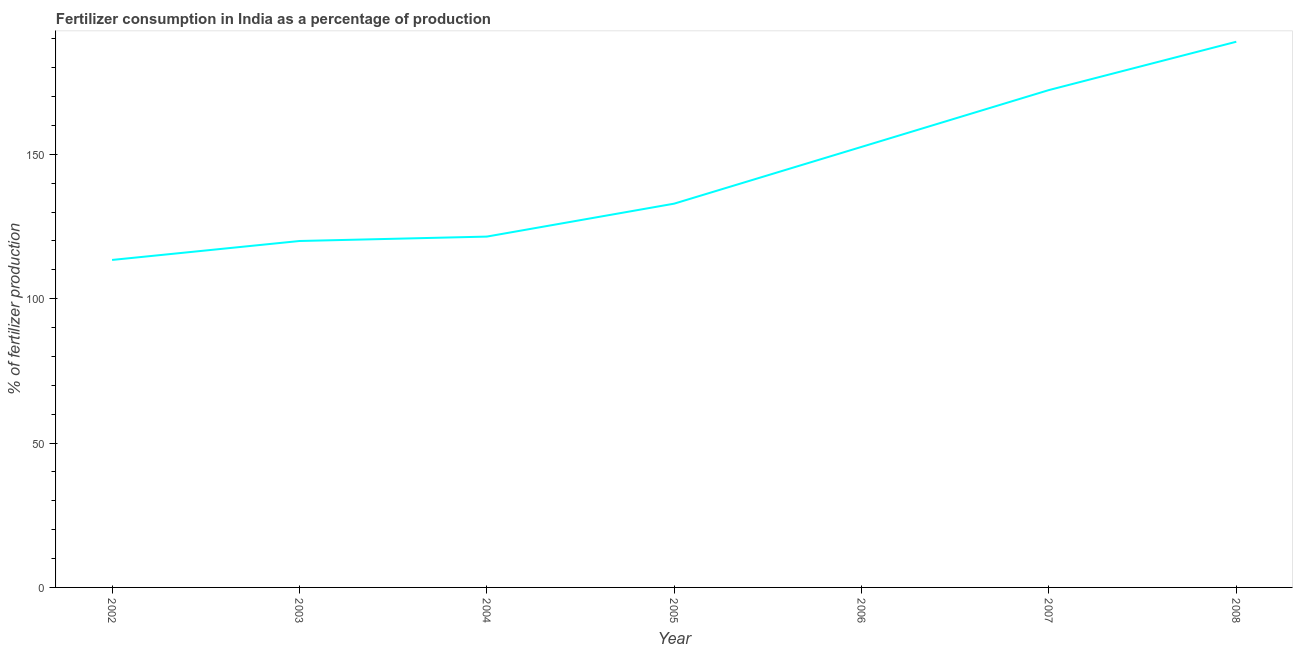What is the amount of fertilizer consumption in 2002?
Your response must be concise. 113.4. Across all years, what is the maximum amount of fertilizer consumption?
Ensure brevity in your answer.  188.97. Across all years, what is the minimum amount of fertilizer consumption?
Keep it short and to the point. 113.4. What is the sum of the amount of fertilizer consumption?
Offer a terse response. 1001.49. What is the difference between the amount of fertilizer consumption in 2005 and 2007?
Make the answer very short. -39.33. What is the average amount of fertilizer consumption per year?
Offer a terse response. 143.07. What is the median amount of fertilizer consumption?
Provide a short and direct response. 132.9. Do a majority of the years between 2004 and 2003 (inclusive) have amount of fertilizer consumption greater than 30 %?
Your answer should be compact. No. What is the ratio of the amount of fertilizer consumption in 2005 to that in 2007?
Keep it short and to the point. 0.77. What is the difference between the highest and the second highest amount of fertilizer consumption?
Ensure brevity in your answer.  16.73. Is the sum of the amount of fertilizer consumption in 2002 and 2005 greater than the maximum amount of fertilizer consumption across all years?
Provide a short and direct response. Yes. What is the difference between the highest and the lowest amount of fertilizer consumption?
Offer a very short reply. 75.56. How many years are there in the graph?
Provide a succinct answer. 7. Are the values on the major ticks of Y-axis written in scientific E-notation?
Your answer should be compact. No. Does the graph contain any zero values?
Offer a terse response. No. What is the title of the graph?
Keep it short and to the point. Fertilizer consumption in India as a percentage of production. What is the label or title of the X-axis?
Your response must be concise. Year. What is the label or title of the Y-axis?
Ensure brevity in your answer.  % of fertilizer production. What is the % of fertilizer production in 2002?
Provide a short and direct response. 113.4. What is the % of fertilizer production of 2003?
Offer a terse response. 119.96. What is the % of fertilizer production of 2004?
Keep it short and to the point. 121.49. What is the % of fertilizer production in 2005?
Make the answer very short. 132.9. What is the % of fertilizer production in 2006?
Ensure brevity in your answer.  152.55. What is the % of fertilizer production in 2007?
Provide a short and direct response. 172.23. What is the % of fertilizer production of 2008?
Offer a very short reply. 188.97. What is the difference between the % of fertilizer production in 2002 and 2003?
Provide a succinct answer. -6.56. What is the difference between the % of fertilizer production in 2002 and 2004?
Offer a terse response. -8.09. What is the difference between the % of fertilizer production in 2002 and 2005?
Provide a short and direct response. -19.49. What is the difference between the % of fertilizer production in 2002 and 2006?
Keep it short and to the point. -39.15. What is the difference between the % of fertilizer production in 2002 and 2007?
Your answer should be compact. -58.83. What is the difference between the % of fertilizer production in 2002 and 2008?
Make the answer very short. -75.56. What is the difference between the % of fertilizer production in 2003 and 2004?
Make the answer very short. -1.53. What is the difference between the % of fertilizer production in 2003 and 2005?
Keep it short and to the point. -12.93. What is the difference between the % of fertilizer production in 2003 and 2006?
Your response must be concise. -32.59. What is the difference between the % of fertilizer production in 2003 and 2007?
Make the answer very short. -52.27. What is the difference between the % of fertilizer production in 2003 and 2008?
Provide a short and direct response. -69. What is the difference between the % of fertilizer production in 2004 and 2005?
Your answer should be very brief. -11.41. What is the difference between the % of fertilizer production in 2004 and 2006?
Provide a short and direct response. -31.06. What is the difference between the % of fertilizer production in 2004 and 2007?
Provide a short and direct response. -50.74. What is the difference between the % of fertilizer production in 2004 and 2008?
Keep it short and to the point. -67.48. What is the difference between the % of fertilizer production in 2005 and 2006?
Keep it short and to the point. -19.66. What is the difference between the % of fertilizer production in 2005 and 2007?
Make the answer very short. -39.33. What is the difference between the % of fertilizer production in 2005 and 2008?
Your response must be concise. -56.07. What is the difference between the % of fertilizer production in 2006 and 2007?
Provide a succinct answer. -19.68. What is the difference between the % of fertilizer production in 2006 and 2008?
Your response must be concise. -36.41. What is the difference between the % of fertilizer production in 2007 and 2008?
Your answer should be very brief. -16.73. What is the ratio of the % of fertilizer production in 2002 to that in 2003?
Your answer should be very brief. 0.94. What is the ratio of the % of fertilizer production in 2002 to that in 2004?
Give a very brief answer. 0.93. What is the ratio of the % of fertilizer production in 2002 to that in 2005?
Make the answer very short. 0.85. What is the ratio of the % of fertilizer production in 2002 to that in 2006?
Provide a short and direct response. 0.74. What is the ratio of the % of fertilizer production in 2002 to that in 2007?
Give a very brief answer. 0.66. What is the ratio of the % of fertilizer production in 2002 to that in 2008?
Your response must be concise. 0.6. What is the ratio of the % of fertilizer production in 2003 to that in 2005?
Offer a terse response. 0.9. What is the ratio of the % of fertilizer production in 2003 to that in 2006?
Your answer should be compact. 0.79. What is the ratio of the % of fertilizer production in 2003 to that in 2007?
Your response must be concise. 0.7. What is the ratio of the % of fertilizer production in 2003 to that in 2008?
Your answer should be very brief. 0.64. What is the ratio of the % of fertilizer production in 2004 to that in 2005?
Provide a succinct answer. 0.91. What is the ratio of the % of fertilizer production in 2004 to that in 2006?
Provide a succinct answer. 0.8. What is the ratio of the % of fertilizer production in 2004 to that in 2007?
Make the answer very short. 0.7. What is the ratio of the % of fertilizer production in 2004 to that in 2008?
Provide a succinct answer. 0.64. What is the ratio of the % of fertilizer production in 2005 to that in 2006?
Provide a succinct answer. 0.87. What is the ratio of the % of fertilizer production in 2005 to that in 2007?
Keep it short and to the point. 0.77. What is the ratio of the % of fertilizer production in 2005 to that in 2008?
Your response must be concise. 0.7. What is the ratio of the % of fertilizer production in 2006 to that in 2007?
Give a very brief answer. 0.89. What is the ratio of the % of fertilizer production in 2006 to that in 2008?
Your response must be concise. 0.81. What is the ratio of the % of fertilizer production in 2007 to that in 2008?
Offer a very short reply. 0.91. 